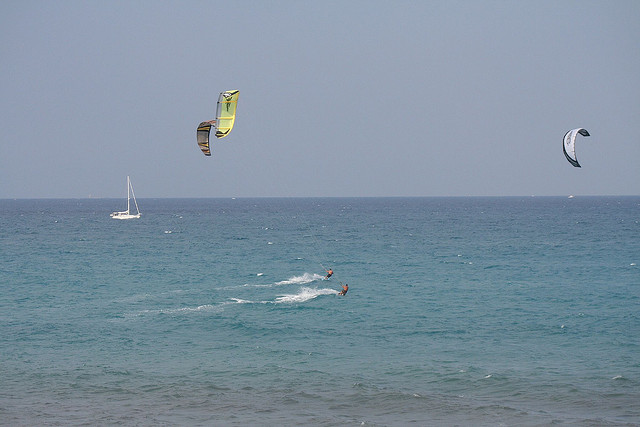Can you discuss the dynamics of parasailing based on what you see? Certainly! Kite surfing, as seen in the image, involves riders being propelled over the water by large kites that catch the wind. The kites are tethered to the surfers, who use boards similar to surfboards. The wind provides lift and forward momentum, enabling surfers to glide, make jumps, turns, and various maneuvers. The ocean provides an open space, making kite surfing both challenging and exhilarating. 